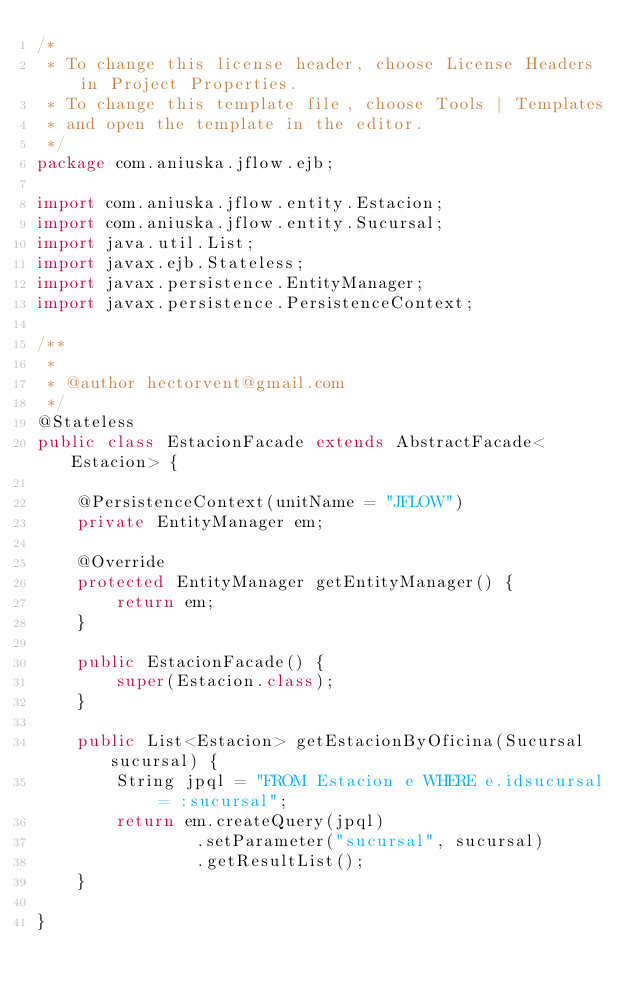<code> <loc_0><loc_0><loc_500><loc_500><_Java_>/*
 * To change this license header, choose License Headers in Project Properties.
 * To change this template file, choose Tools | Templates
 * and open the template in the editor.
 */
package com.aniuska.jflow.ejb;

import com.aniuska.jflow.entity.Estacion;
import com.aniuska.jflow.entity.Sucursal;
import java.util.List;
import javax.ejb.Stateless;
import javax.persistence.EntityManager;
import javax.persistence.PersistenceContext;

/**
 *
 * @author hectorvent@gmail.com
 */
@Stateless
public class EstacionFacade extends AbstractFacade<Estacion> {

    @PersistenceContext(unitName = "JFLOW")
    private EntityManager em;

    @Override
    protected EntityManager getEntityManager() {
        return em;
    }

    public EstacionFacade() {
        super(Estacion.class);
    }

    public List<Estacion> getEstacionByOficina(Sucursal sucursal) {
        String jpql = "FROM Estacion e WHERE e.idsucursal = :sucursal";
        return em.createQuery(jpql)
                .setParameter("sucursal", sucursal)
                .getResultList();
    }

}
</code> 